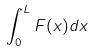Convert formula to latex. <formula><loc_0><loc_0><loc_500><loc_500>\int _ { 0 } ^ { L } F ( x ) d x</formula> 